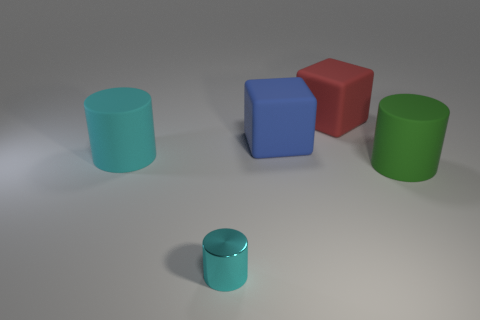Subtract all shiny cylinders. How many cylinders are left? 2 Subtract all green cylinders. How many cylinders are left? 2 Add 3 big cyan matte objects. How many objects exist? 8 Subtract all red blocks. How many cyan cylinders are left? 2 Add 2 small metal objects. How many small metal objects exist? 3 Subtract 0 brown blocks. How many objects are left? 5 Subtract all cylinders. How many objects are left? 2 Subtract all green cylinders. Subtract all green spheres. How many cylinders are left? 2 Subtract all tiny cylinders. Subtract all green matte things. How many objects are left? 3 Add 3 large cyan rubber cylinders. How many large cyan rubber cylinders are left? 4 